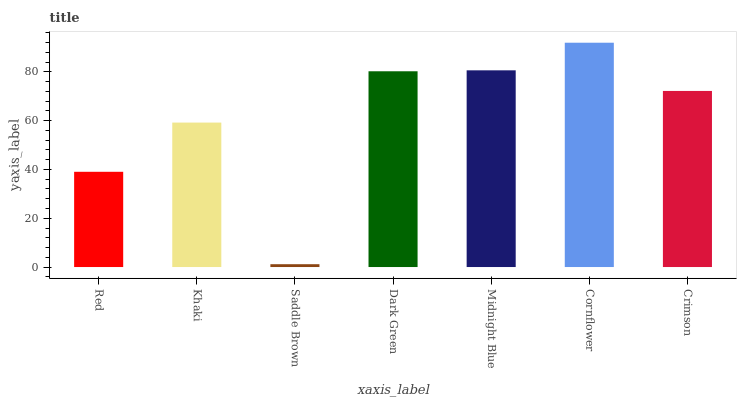Is Saddle Brown the minimum?
Answer yes or no. Yes. Is Cornflower the maximum?
Answer yes or no. Yes. Is Khaki the minimum?
Answer yes or no. No. Is Khaki the maximum?
Answer yes or no. No. Is Khaki greater than Red?
Answer yes or no. Yes. Is Red less than Khaki?
Answer yes or no. Yes. Is Red greater than Khaki?
Answer yes or no. No. Is Khaki less than Red?
Answer yes or no. No. Is Crimson the high median?
Answer yes or no. Yes. Is Crimson the low median?
Answer yes or no. Yes. Is Midnight Blue the high median?
Answer yes or no. No. Is Saddle Brown the low median?
Answer yes or no. No. 